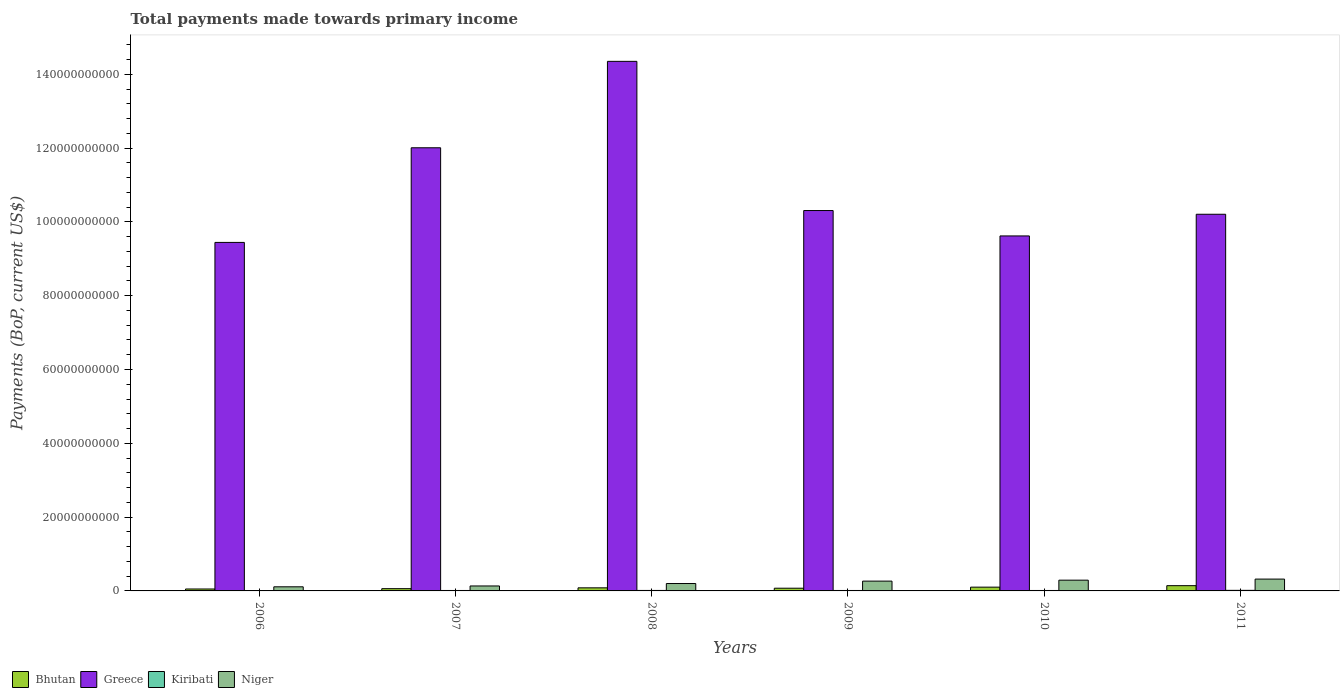Are the number of bars per tick equal to the number of legend labels?
Your answer should be very brief. Yes. Are the number of bars on each tick of the X-axis equal?
Your response must be concise. Yes. What is the label of the 3rd group of bars from the left?
Offer a terse response. 2008. In how many cases, is the number of bars for a given year not equal to the number of legend labels?
Give a very brief answer. 0. What is the total payments made towards primary income in Niger in 2008?
Provide a succinct answer. 2.01e+09. Across all years, what is the maximum total payments made towards primary income in Niger?
Your response must be concise. 3.21e+09. Across all years, what is the minimum total payments made towards primary income in Niger?
Offer a very short reply. 1.12e+09. In which year was the total payments made towards primary income in Greece minimum?
Keep it short and to the point. 2006. What is the total total payments made towards primary income in Niger in the graph?
Ensure brevity in your answer.  1.32e+1. What is the difference between the total payments made towards primary income in Niger in 2010 and that in 2011?
Your answer should be very brief. -2.90e+08. What is the difference between the total payments made towards primary income in Kiribati in 2008 and the total payments made towards primary income in Greece in 2010?
Make the answer very short. -9.61e+1. What is the average total payments made towards primary income in Kiribati per year?
Offer a terse response. 1.24e+08. In the year 2008, what is the difference between the total payments made towards primary income in Greece and total payments made towards primary income in Niger?
Ensure brevity in your answer.  1.42e+11. In how many years, is the total payments made towards primary income in Greece greater than 72000000000 US$?
Your answer should be compact. 6. What is the ratio of the total payments made towards primary income in Niger in 2007 to that in 2011?
Provide a succinct answer. 0.42. Is the difference between the total payments made towards primary income in Greece in 2007 and 2009 greater than the difference between the total payments made towards primary income in Niger in 2007 and 2009?
Ensure brevity in your answer.  Yes. What is the difference between the highest and the second highest total payments made towards primary income in Niger?
Your answer should be compact. 2.90e+08. What is the difference between the highest and the lowest total payments made towards primary income in Kiribati?
Provide a short and direct response. 5.52e+07. In how many years, is the total payments made towards primary income in Niger greater than the average total payments made towards primary income in Niger taken over all years?
Provide a short and direct response. 3. Is the sum of the total payments made towards primary income in Bhutan in 2006 and 2011 greater than the maximum total payments made towards primary income in Kiribati across all years?
Provide a succinct answer. Yes. Is it the case that in every year, the sum of the total payments made towards primary income in Bhutan and total payments made towards primary income in Kiribati is greater than the sum of total payments made towards primary income in Niger and total payments made towards primary income in Greece?
Offer a terse response. No. What does the 1st bar from the left in 2006 represents?
Make the answer very short. Bhutan. What does the 1st bar from the right in 2006 represents?
Keep it short and to the point. Niger. Is it the case that in every year, the sum of the total payments made towards primary income in Kiribati and total payments made towards primary income in Niger is greater than the total payments made towards primary income in Bhutan?
Offer a terse response. Yes. How many bars are there?
Your answer should be very brief. 24. How many years are there in the graph?
Make the answer very short. 6. What is the difference between two consecutive major ticks on the Y-axis?
Offer a terse response. 2.00e+1. Does the graph contain grids?
Provide a short and direct response. No. How are the legend labels stacked?
Make the answer very short. Horizontal. What is the title of the graph?
Offer a terse response. Total payments made towards primary income. Does "Sudan" appear as one of the legend labels in the graph?
Keep it short and to the point. No. What is the label or title of the Y-axis?
Provide a short and direct response. Payments (BoP, current US$). What is the Payments (BoP, current US$) in Bhutan in 2006?
Make the answer very short. 5.25e+08. What is the Payments (BoP, current US$) of Greece in 2006?
Make the answer very short. 9.44e+1. What is the Payments (BoP, current US$) of Kiribati in 2006?
Keep it short and to the point. 9.98e+07. What is the Payments (BoP, current US$) of Niger in 2006?
Provide a short and direct response. 1.12e+09. What is the Payments (BoP, current US$) in Bhutan in 2007?
Keep it short and to the point. 6.13e+08. What is the Payments (BoP, current US$) in Greece in 2007?
Keep it short and to the point. 1.20e+11. What is the Payments (BoP, current US$) in Kiribati in 2007?
Provide a succinct answer. 1.19e+08. What is the Payments (BoP, current US$) in Niger in 2007?
Provide a succinct answer. 1.34e+09. What is the Payments (BoP, current US$) in Bhutan in 2008?
Your response must be concise. 8.35e+08. What is the Payments (BoP, current US$) in Greece in 2008?
Ensure brevity in your answer.  1.44e+11. What is the Payments (BoP, current US$) of Kiribati in 2008?
Your answer should be very brief. 1.30e+08. What is the Payments (BoP, current US$) of Niger in 2008?
Give a very brief answer. 2.01e+09. What is the Payments (BoP, current US$) in Bhutan in 2009?
Keep it short and to the point. 7.35e+08. What is the Payments (BoP, current US$) in Greece in 2009?
Keep it short and to the point. 1.03e+11. What is the Payments (BoP, current US$) of Kiribati in 2009?
Offer a terse response. 1.20e+08. What is the Payments (BoP, current US$) of Niger in 2009?
Keep it short and to the point. 2.66e+09. What is the Payments (BoP, current US$) of Bhutan in 2010?
Make the answer very short. 1.02e+09. What is the Payments (BoP, current US$) in Greece in 2010?
Ensure brevity in your answer.  9.62e+1. What is the Payments (BoP, current US$) in Kiribati in 2010?
Offer a terse response. 1.21e+08. What is the Payments (BoP, current US$) in Niger in 2010?
Your response must be concise. 2.92e+09. What is the Payments (BoP, current US$) in Bhutan in 2011?
Make the answer very short. 1.43e+09. What is the Payments (BoP, current US$) in Greece in 2011?
Keep it short and to the point. 1.02e+11. What is the Payments (BoP, current US$) of Kiribati in 2011?
Your response must be concise. 1.55e+08. What is the Payments (BoP, current US$) in Niger in 2011?
Your response must be concise. 3.21e+09. Across all years, what is the maximum Payments (BoP, current US$) of Bhutan?
Make the answer very short. 1.43e+09. Across all years, what is the maximum Payments (BoP, current US$) in Greece?
Your response must be concise. 1.44e+11. Across all years, what is the maximum Payments (BoP, current US$) in Kiribati?
Provide a short and direct response. 1.55e+08. Across all years, what is the maximum Payments (BoP, current US$) of Niger?
Offer a very short reply. 3.21e+09. Across all years, what is the minimum Payments (BoP, current US$) of Bhutan?
Keep it short and to the point. 5.25e+08. Across all years, what is the minimum Payments (BoP, current US$) in Greece?
Offer a very short reply. 9.44e+1. Across all years, what is the minimum Payments (BoP, current US$) in Kiribati?
Provide a succinct answer. 9.98e+07. Across all years, what is the minimum Payments (BoP, current US$) of Niger?
Give a very brief answer. 1.12e+09. What is the total Payments (BoP, current US$) in Bhutan in the graph?
Give a very brief answer. 5.16e+09. What is the total Payments (BoP, current US$) in Greece in the graph?
Offer a very short reply. 6.59e+11. What is the total Payments (BoP, current US$) of Kiribati in the graph?
Provide a succinct answer. 7.46e+08. What is the total Payments (BoP, current US$) in Niger in the graph?
Your answer should be very brief. 1.32e+1. What is the difference between the Payments (BoP, current US$) in Bhutan in 2006 and that in 2007?
Your answer should be compact. -8.84e+07. What is the difference between the Payments (BoP, current US$) in Greece in 2006 and that in 2007?
Provide a short and direct response. -2.56e+1. What is the difference between the Payments (BoP, current US$) of Kiribati in 2006 and that in 2007?
Ensure brevity in your answer.  -1.92e+07. What is the difference between the Payments (BoP, current US$) of Niger in 2006 and that in 2007?
Provide a succinct answer. -2.25e+08. What is the difference between the Payments (BoP, current US$) of Bhutan in 2006 and that in 2008?
Your response must be concise. -3.11e+08. What is the difference between the Payments (BoP, current US$) of Greece in 2006 and that in 2008?
Your answer should be compact. -4.91e+1. What is the difference between the Payments (BoP, current US$) in Kiribati in 2006 and that in 2008?
Provide a succinct answer. -3.06e+07. What is the difference between the Payments (BoP, current US$) of Niger in 2006 and that in 2008?
Your answer should be very brief. -8.89e+08. What is the difference between the Payments (BoP, current US$) of Bhutan in 2006 and that in 2009?
Keep it short and to the point. -2.10e+08. What is the difference between the Payments (BoP, current US$) of Greece in 2006 and that in 2009?
Keep it short and to the point. -8.64e+09. What is the difference between the Payments (BoP, current US$) of Kiribati in 2006 and that in 2009?
Ensure brevity in your answer.  -2.04e+07. What is the difference between the Payments (BoP, current US$) of Niger in 2006 and that in 2009?
Offer a terse response. -1.54e+09. What is the difference between the Payments (BoP, current US$) of Bhutan in 2006 and that in 2010?
Make the answer very short. -4.99e+08. What is the difference between the Payments (BoP, current US$) in Greece in 2006 and that in 2010?
Offer a terse response. -1.76e+09. What is the difference between the Payments (BoP, current US$) of Kiribati in 2006 and that in 2010?
Your response must be concise. -2.11e+07. What is the difference between the Payments (BoP, current US$) in Niger in 2006 and that in 2010?
Your answer should be very brief. -1.80e+09. What is the difference between the Payments (BoP, current US$) in Bhutan in 2006 and that in 2011?
Provide a succinct answer. -9.01e+08. What is the difference between the Payments (BoP, current US$) in Greece in 2006 and that in 2011?
Give a very brief answer. -7.63e+09. What is the difference between the Payments (BoP, current US$) of Kiribati in 2006 and that in 2011?
Provide a succinct answer. -5.52e+07. What is the difference between the Payments (BoP, current US$) in Niger in 2006 and that in 2011?
Offer a very short reply. -2.09e+09. What is the difference between the Payments (BoP, current US$) of Bhutan in 2007 and that in 2008?
Keep it short and to the point. -2.22e+08. What is the difference between the Payments (BoP, current US$) of Greece in 2007 and that in 2008?
Give a very brief answer. -2.34e+1. What is the difference between the Payments (BoP, current US$) of Kiribati in 2007 and that in 2008?
Offer a terse response. -1.14e+07. What is the difference between the Payments (BoP, current US$) of Niger in 2007 and that in 2008?
Make the answer very short. -6.63e+08. What is the difference between the Payments (BoP, current US$) of Bhutan in 2007 and that in 2009?
Make the answer very short. -1.22e+08. What is the difference between the Payments (BoP, current US$) in Greece in 2007 and that in 2009?
Give a very brief answer. 1.70e+1. What is the difference between the Payments (BoP, current US$) of Kiribati in 2007 and that in 2009?
Offer a terse response. -1.23e+06. What is the difference between the Payments (BoP, current US$) in Niger in 2007 and that in 2009?
Provide a succinct answer. -1.31e+09. What is the difference between the Payments (BoP, current US$) of Bhutan in 2007 and that in 2010?
Make the answer very short. -4.11e+08. What is the difference between the Payments (BoP, current US$) in Greece in 2007 and that in 2010?
Your answer should be very brief. 2.39e+1. What is the difference between the Payments (BoP, current US$) in Kiribati in 2007 and that in 2010?
Keep it short and to the point. -1.95e+06. What is the difference between the Payments (BoP, current US$) in Niger in 2007 and that in 2010?
Your answer should be compact. -1.57e+09. What is the difference between the Payments (BoP, current US$) of Bhutan in 2007 and that in 2011?
Give a very brief answer. -8.12e+08. What is the difference between the Payments (BoP, current US$) in Greece in 2007 and that in 2011?
Provide a short and direct response. 1.80e+1. What is the difference between the Payments (BoP, current US$) in Kiribati in 2007 and that in 2011?
Ensure brevity in your answer.  -3.61e+07. What is the difference between the Payments (BoP, current US$) of Niger in 2007 and that in 2011?
Offer a very short reply. -1.86e+09. What is the difference between the Payments (BoP, current US$) in Bhutan in 2008 and that in 2009?
Offer a very short reply. 1.00e+08. What is the difference between the Payments (BoP, current US$) in Greece in 2008 and that in 2009?
Offer a very short reply. 4.04e+1. What is the difference between the Payments (BoP, current US$) of Kiribati in 2008 and that in 2009?
Provide a short and direct response. 1.02e+07. What is the difference between the Payments (BoP, current US$) in Niger in 2008 and that in 2009?
Provide a short and direct response. -6.50e+08. What is the difference between the Payments (BoP, current US$) of Bhutan in 2008 and that in 2010?
Offer a very short reply. -1.88e+08. What is the difference between the Payments (BoP, current US$) in Greece in 2008 and that in 2010?
Your answer should be very brief. 4.73e+1. What is the difference between the Payments (BoP, current US$) in Kiribati in 2008 and that in 2010?
Offer a terse response. 9.45e+06. What is the difference between the Payments (BoP, current US$) of Niger in 2008 and that in 2010?
Make the answer very short. -9.10e+08. What is the difference between the Payments (BoP, current US$) in Bhutan in 2008 and that in 2011?
Your answer should be compact. -5.90e+08. What is the difference between the Payments (BoP, current US$) in Greece in 2008 and that in 2011?
Your response must be concise. 4.14e+1. What is the difference between the Payments (BoP, current US$) of Kiribati in 2008 and that in 2011?
Keep it short and to the point. -2.46e+07. What is the difference between the Payments (BoP, current US$) of Niger in 2008 and that in 2011?
Ensure brevity in your answer.  -1.20e+09. What is the difference between the Payments (BoP, current US$) of Bhutan in 2009 and that in 2010?
Your answer should be compact. -2.89e+08. What is the difference between the Payments (BoP, current US$) of Greece in 2009 and that in 2010?
Give a very brief answer. 6.88e+09. What is the difference between the Payments (BoP, current US$) of Kiribati in 2009 and that in 2010?
Your answer should be very brief. -7.21e+05. What is the difference between the Payments (BoP, current US$) of Niger in 2009 and that in 2010?
Ensure brevity in your answer.  -2.59e+08. What is the difference between the Payments (BoP, current US$) in Bhutan in 2009 and that in 2011?
Provide a succinct answer. -6.90e+08. What is the difference between the Payments (BoP, current US$) in Greece in 2009 and that in 2011?
Offer a terse response. 1.01e+09. What is the difference between the Payments (BoP, current US$) in Kiribati in 2009 and that in 2011?
Your answer should be very brief. -3.48e+07. What is the difference between the Payments (BoP, current US$) of Niger in 2009 and that in 2011?
Ensure brevity in your answer.  -5.50e+08. What is the difference between the Payments (BoP, current US$) of Bhutan in 2010 and that in 2011?
Your answer should be very brief. -4.02e+08. What is the difference between the Payments (BoP, current US$) of Greece in 2010 and that in 2011?
Your response must be concise. -5.87e+09. What is the difference between the Payments (BoP, current US$) in Kiribati in 2010 and that in 2011?
Make the answer very short. -3.41e+07. What is the difference between the Payments (BoP, current US$) of Niger in 2010 and that in 2011?
Your response must be concise. -2.90e+08. What is the difference between the Payments (BoP, current US$) in Bhutan in 2006 and the Payments (BoP, current US$) in Greece in 2007?
Provide a short and direct response. -1.20e+11. What is the difference between the Payments (BoP, current US$) of Bhutan in 2006 and the Payments (BoP, current US$) of Kiribati in 2007?
Keep it short and to the point. 4.06e+08. What is the difference between the Payments (BoP, current US$) of Bhutan in 2006 and the Payments (BoP, current US$) of Niger in 2007?
Your answer should be compact. -8.18e+08. What is the difference between the Payments (BoP, current US$) of Greece in 2006 and the Payments (BoP, current US$) of Kiribati in 2007?
Keep it short and to the point. 9.43e+1. What is the difference between the Payments (BoP, current US$) in Greece in 2006 and the Payments (BoP, current US$) in Niger in 2007?
Your response must be concise. 9.31e+1. What is the difference between the Payments (BoP, current US$) in Kiribati in 2006 and the Payments (BoP, current US$) in Niger in 2007?
Keep it short and to the point. -1.24e+09. What is the difference between the Payments (BoP, current US$) in Bhutan in 2006 and the Payments (BoP, current US$) in Greece in 2008?
Your response must be concise. -1.43e+11. What is the difference between the Payments (BoP, current US$) of Bhutan in 2006 and the Payments (BoP, current US$) of Kiribati in 2008?
Keep it short and to the point. 3.94e+08. What is the difference between the Payments (BoP, current US$) in Bhutan in 2006 and the Payments (BoP, current US$) in Niger in 2008?
Your answer should be compact. -1.48e+09. What is the difference between the Payments (BoP, current US$) in Greece in 2006 and the Payments (BoP, current US$) in Kiribati in 2008?
Ensure brevity in your answer.  9.43e+1. What is the difference between the Payments (BoP, current US$) of Greece in 2006 and the Payments (BoP, current US$) of Niger in 2008?
Offer a very short reply. 9.24e+1. What is the difference between the Payments (BoP, current US$) of Kiribati in 2006 and the Payments (BoP, current US$) of Niger in 2008?
Your answer should be very brief. -1.91e+09. What is the difference between the Payments (BoP, current US$) in Bhutan in 2006 and the Payments (BoP, current US$) in Greece in 2009?
Provide a succinct answer. -1.03e+11. What is the difference between the Payments (BoP, current US$) in Bhutan in 2006 and the Payments (BoP, current US$) in Kiribati in 2009?
Provide a succinct answer. 4.04e+08. What is the difference between the Payments (BoP, current US$) of Bhutan in 2006 and the Payments (BoP, current US$) of Niger in 2009?
Your response must be concise. -2.13e+09. What is the difference between the Payments (BoP, current US$) of Greece in 2006 and the Payments (BoP, current US$) of Kiribati in 2009?
Offer a very short reply. 9.43e+1. What is the difference between the Payments (BoP, current US$) of Greece in 2006 and the Payments (BoP, current US$) of Niger in 2009?
Ensure brevity in your answer.  9.18e+1. What is the difference between the Payments (BoP, current US$) of Kiribati in 2006 and the Payments (BoP, current US$) of Niger in 2009?
Your answer should be very brief. -2.56e+09. What is the difference between the Payments (BoP, current US$) of Bhutan in 2006 and the Payments (BoP, current US$) of Greece in 2010?
Offer a very short reply. -9.57e+1. What is the difference between the Payments (BoP, current US$) of Bhutan in 2006 and the Payments (BoP, current US$) of Kiribati in 2010?
Offer a terse response. 4.04e+08. What is the difference between the Payments (BoP, current US$) of Bhutan in 2006 and the Payments (BoP, current US$) of Niger in 2010?
Your answer should be very brief. -2.39e+09. What is the difference between the Payments (BoP, current US$) of Greece in 2006 and the Payments (BoP, current US$) of Kiribati in 2010?
Your answer should be compact. 9.43e+1. What is the difference between the Payments (BoP, current US$) of Greece in 2006 and the Payments (BoP, current US$) of Niger in 2010?
Ensure brevity in your answer.  9.15e+1. What is the difference between the Payments (BoP, current US$) in Kiribati in 2006 and the Payments (BoP, current US$) in Niger in 2010?
Give a very brief answer. -2.82e+09. What is the difference between the Payments (BoP, current US$) of Bhutan in 2006 and the Payments (BoP, current US$) of Greece in 2011?
Make the answer very short. -1.02e+11. What is the difference between the Payments (BoP, current US$) in Bhutan in 2006 and the Payments (BoP, current US$) in Kiribati in 2011?
Offer a very short reply. 3.69e+08. What is the difference between the Payments (BoP, current US$) of Bhutan in 2006 and the Payments (BoP, current US$) of Niger in 2011?
Offer a very short reply. -2.68e+09. What is the difference between the Payments (BoP, current US$) of Greece in 2006 and the Payments (BoP, current US$) of Kiribati in 2011?
Offer a very short reply. 9.43e+1. What is the difference between the Payments (BoP, current US$) of Greece in 2006 and the Payments (BoP, current US$) of Niger in 2011?
Keep it short and to the point. 9.12e+1. What is the difference between the Payments (BoP, current US$) of Kiribati in 2006 and the Payments (BoP, current US$) of Niger in 2011?
Keep it short and to the point. -3.11e+09. What is the difference between the Payments (BoP, current US$) of Bhutan in 2007 and the Payments (BoP, current US$) of Greece in 2008?
Keep it short and to the point. -1.43e+11. What is the difference between the Payments (BoP, current US$) in Bhutan in 2007 and the Payments (BoP, current US$) in Kiribati in 2008?
Give a very brief answer. 4.83e+08. What is the difference between the Payments (BoP, current US$) in Bhutan in 2007 and the Payments (BoP, current US$) in Niger in 2008?
Provide a succinct answer. -1.39e+09. What is the difference between the Payments (BoP, current US$) in Greece in 2007 and the Payments (BoP, current US$) in Kiribati in 2008?
Ensure brevity in your answer.  1.20e+11. What is the difference between the Payments (BoP, current US$) of Greece in 2007 and the Payments (BoP, current US$) of Niger in 2008?
Your answer should be compact. 1.18e+11. What is the difference between the Payments (BoP, current US$) in Kiribati in 2007 and the Payments (BoP, current US$) in Niger in 2008?
Your answer should be very brief. -1.89e+09. What is the difference between the Payments (BoP, current US$) of Bhutan in 2007 and the Payments (BoP, current US$) of Greece in 2009?
Ensure brevity in your answer.  -1.02e+11. What is the difference between the Payments (BoP, current US$) of Bhutan in 2007 and the Payments (BoP, current US$) of Kiribati in 2009?
Give a very brief answer. 4.93e+08. What is the difference between the Payments (BoP, current US$) of Bhutan in 2007 and the Payments (BoP, current US$) of Niger in 2009?
Offer a terse response. -2.04e+09. What is the difference between the Payments (BoP, current US$) in Greece in 2007 and the Payments (BoP, current US$) in Kiribati in 2009?
Give a very brief answer. 1.20e+11. What is the difference between the Payments (BoP, current US$) of Greece in 2007 and the Payments (BoP, current US$) of Niger in 2009?
Your response must be concise. 1.17e+11. What is the difference between the Payments (BoP, current US$) of Kiribati in 2007 and the Payments (BoP, current US$) of Niger in 2009?
Keep it short and to the point. -2.54e+09. What is the difference between the Payments (BoP, current US$) in Bhutan in 2007 and the Payments (BoP, current US$) in Greece in 2010?
Offer a terse response. -9.56e+1. What is the difference between the Payments (BoP, current US$) of Bhutan in 2007 and the Payments (BoP, current US$) of Kiribati in 2010?
Your response must be concise. 4.92e+08. What is the difference between the Payments (BoP, current US$) of Bhutan in 2007 and the Payments (BoP, current US$) of Niger in 2010?
Offer a very short reply. -2.30e+09. What is the difference between the Payments (BoP, current US$) of Greece in 2007 and the Payments (BoP, current US$) of Kiribati in 2010?
Make the answer very short. 1.20e+11. What is the difference between the Payments (BoP, current US$) of Greece in 2007 and the Payments (BoP, current US$) of Niger in 2010?
Keep it short and to the point. 1.17e+11. What is the difference between the Payments (BoP, current US$) of Kiribati in 2007 and the Payments (BoP, current US$) of Niger in 2010?
Provide a succinct answer. -2.80e+09. What is the difference between the Payments (BoP, current US$) in Bhutan in 2007 and the Payments (BoP, current US$) in Greece in 2011?
Keep it short and to the point. -1.01e+11. What is the difference between the Payments (BoP, current US$) in Bhutan in 2007 and the Payments (BoP, current US$) in Kiribati in 2011?
Ensure brevity in your answer.  4.58e+08. What is the difference between the Payments (BoP, current US$) of Bhutan in 2007 and the Payments (BoP, current US$) of Niger in 2011?
Give a very brief answer. -2.59e+09. What is the difference between the Payments (BoP, current US$) in Greece in 2007 and the Payments (BoP, current US$) in Kiribati in 2011?
Your answer should be compact. 1.20e+11. What is the difference between the Payments (BoP, current US$) in Greece in 2007 and the Payments (BoP, current US$) in Niger in 2011?
Provide a short and direct response. 1.17e+11. What is the difference between the Payments (BoP, current US$) of Kiribati in 2007 and the Payments (BoP, current US$) of Niger in 2011?
Offer a very short reply. -3.09e+09. What is the difference between the Payments (BoP, current US$) in Bhutan in 2008 and the Payments (BoP, current US$) in Greece in 2009?
Make the answer very short. -1.02e+11. What is the difference between the Payments (BoP, current US$) in Bhutan in 2008 and the Payments (BoP, current US$) in Kiribati in 2009?
Your response must be concise. 7.15e+08. What is the difference between the Payments (BoP, current US$) of Bhutan in 2008 and the Payments (BoP, current US$) of Niger in 2009?
Provide a succinct answer. -1.82e+09. What is the difference between the Payments (BoP, current US$) in Greece in 2008 and the Payments (BoP, current US$) in Kiribati in 2009?
Your answer should be compact. 1.43e+11. What is the difference between the Payments (BoP, current US$) of Greece in 2008 and the Payments (BoP, current US$) of Niger in 2009?
Offer a very short reply. 1.41e+11. What is the difference between the Payments (BoP, current US$) of Kiribati in 2008 and the Payments (BoP, current US$) of Niger in 2009?
Ensure brevity in your answer.  -2.53e+09. What is the difference between the Payments (BoP, current US$) in Bhutan in 2008 and the Payments (BoP, current US$) in Greece in 2010?
Offer a very short reply. -9.54e+1. What is the difference between the Payments (BoP, current US$) in Bhutan in 2008 and the Payments (BoP, current US$) in Kiribati in 2010?
Your response must be concise. 7.14e+08. What is the difference between the Payments (BoP, current US$) in Bhutan in 2008 and the Payments (BoP, current US$) in Niger in 2010?
Your answer should be very brief. -2.08e+09. What is the difference between the Payments (BoP, current US$) in Greece in 2008 and the Payments (BoP, current US$) in Kiribati in 2010?
Offer a terse response. 1.43e+11. What is the difference between the Payments (BoP, current US$) in Greece in 2008 and the Payments (BoP, current US$) in Niger in 2010?
Ensure brevity in your answer.  1.41e+11. What is the difference between the Payments (BoP, current US$) of Kiribati in 2008 and the Payments (BoP, current US$) of Niger in 2010?
Make the answer very short. -2.79e+09. What is the difference between the Payments (BoP, current US$) of Bhutan in 2008 and the Payments (BoP, current US$) of Greece in 2011?
Provide a succinct answer. -1.01e+11. What is the difference between the Payments (BoP, current US$) in Bhutan in 2008 and the Payments (BoP, current US$) in Kiribati in 2011?
Ensure brevity in your answer.  6.80e+08. What is the difference between the Payments (BoP, current US$) in Bhutan in 2008 and the Payments (BoP, current US$) in Niger in 2011?
Keep it short and to the point. -2.37e+09. What is the difference between the Payments (BoP, current US$) in Greece in 2008 and the Payments (BoP, current US$) in Kiribati in 2011?
Your response must be concise. 1.43e+11. What is the difference between the Payments (BoP, current US$) of Greece in 2008 and the Payments (BoP, current US$) of Niger in 2011?
Your answer should be compact. 1.40e+11. What is the difference between the Payments (BoP, current US$) in Kiribati in 2008 and the Payments (BoP, current US$) in Niger in 2011?
Offer a very short reply. -3.08e+09. What is the difference between the Payments (BoP, current US$) in Bhutan in 2009 and the Payments (BoP, current US$) in Greece in 2010?
Give a very brief answer. -9.55e+1. What is the difference between the Payments (BoP, current US$) of Bhutan in 2009 and the Payments (BoP, current US$) of Kiribati in 2010?
Ensure brevity in your answer.  6.14e+08. What is the difference between the Payments (BoP, current US$) in Bhutan in 2009 and the Payments (BoP, current US$) in Niger in 2010?
Keep it short and to the point. -2.18e+09. What is the difference between the Payments (BoP, current US$) in Greece in 2009 and the Payments (BoP, current US$) in Kiribati in 2010?
Make the answer very short. 1.03e+11. What is the difference between the Payments (BoP, current US$) of Greece in 2009 and the Payments (BoP, current US$) of Niger in 2010?
Ensure brevity in your answer.  1.00e+11. What is the difference between the Payments (BoP, current US$) in Kiribati in 2009 and the Payments (BoP, current US$) in Niger in 2010?
Make the answer very short. -2.80e+09. What is the difference between the Payments (BoP, current US$) in Bhutan in 2009 and the Payments (BoP, current US$) in Greece in 2011?
Your answer should be compact. -1.01e+11. What is the difference between the Payments (BoP, current US$) in Bhutan in 2009 and the Payments (BoP, current US$) in Kiribati in 2011?
Your response must be concise. 5.80e+08. What is the difference between the Payments (BoP, current US$) of Bhutan in 2009 and the Payments (BoP, current US$) of Niger in 2011?
Make the answer very short. -2.47e+09. What is the difference between the Payments (BoP, current US$) in Greece in 2009 and the Payments (BoP, current US$) in Kiribati in 2011?
Give a very brief answer. 1.03e+11. What is the difference between the Payments (BoP, current US$) in Greece in 2009 and the Payments (BoP, current US$) in Niger in 2011?
Give a very brief answer. 9.99e+1. What is the difference between the Payments (BoP, current US$) in Kiribati in 2009 and the Payments (BoP, current US$) in Niger in 2011?
Keep it short and to the point. -3.09e+09. What is the difference between the Payments (BoP, current US$) of Bhutan in 2010 and the Payments (BoP, current US$) of Greece in 2011?
Provide a short and direct response. -1.01e+11. What is the difference between the Payments (BoP, current US$) in Bhutan in 2010 and the Payments (BoP, current US$) in Kiribati in 2011?
Offer a very short reply. 8.69e+08. What is the difference between the Payments (BoP, current US$) of Bhutan in 2010 and the Payments (BoP, current US$) of Niger in 2011?
Your answer should be compact. -2.18e+09. What is the difference between the Payments (BoP, current US$) in Greece in 2010 and the Payments (BoP, current US$) in Kiribati in 2011?
Offer a terse response. 9.60e+1. What is the difference between the Payments (BoP, current US$) of Greece in 2010 and the Payments (BoP, current US$) of Niger in 2011?
Keep it short and to the point. 9.30e+1. What is the difference between the Payments (BoP, current US$) of Kiribati in 2010 and the Payments (BoP, current US$) of Niger in 2011?
Provide a short and direct response. -3.09e+09. What is the average Payments (BoP, current US$) in Bhutan per year?
Provide a succinct answer. 8.59e+08. What is the average Payments (BoP, current US$) of Greece per year?
Ensure brevity in your answer.  1.10e+11. What is the average Payments (BoP, current US$) of Kiribati per year?
Ensure brevity in your answer.  1.24e+08. What is the average Payments (BoP, current US$) of Niger per year?
Give a very brief answer. 2.21e+09. In the year 2006, what is the difference between the Payments (BoP, current US$) of Bhutan and Payments (BoP, current US$) of Greece?
Your response must be concise. -9.39e+1. In the year 2006, what is the difference between the Payments (BoP, current US$) in Bhutan and Payments (BoP, current US$) in Kiribati?
Make the answer very short. 4.25e+08. In the year 2006, what is the difference between the Payments (BoP, current US$) of Bhutan and Payments (BoP, current US$) of Niger?
Offer a terse response. -5.93e+08. In the year 2006, what is the difference between the Payments (BoP, current US$) of Greece and Payments (BoP, current US$) of Kiribati?
Your answer should be compact. 9.43e+1. In the year 2006, what is the difference between the Payments (BoP, current US$) of Greece and Payments (BoP, current US$) of Niger?
Your answer should be very brief. 9.33e+1. In the year 2006, what is the difference between the Payments (BoP, current US$) of Kiribati and Payments (BoP, current US$) of Niger?
Make the answer very short. -1.02e+09. In the year 2007, what is the difference between the Payments (BoP, current US$) of Bhutan and Payments (BoP, current US$) of Greece?
Keep it short and to the point. -1.19e+11. In the year 2007, what is the difference between the Payments (BoP, current US$) in Bhutan and Payments (BoP, current US$) in Kiribati?
Your answer should be compact. 4.94e+08. In the year 2007, what is the difference between the Payments (BoP, current US$) of Bhutan and Payments (BoP, current US$) of Niger?
Keep it short and to the point. -7.30e+08. In the year 2007, what is the difference between the Payments (BoP, current US$) in Greece and Payments (BoP, current US$) in Kiribati?
Give a very brief answer. 1.20e+11. In the year 2007, what is the difference between the Payments (BoP, current US$) in Greece and Payments (BoP, current US$) in Niger?
Provide a succinct answer. 1.19e+11. In the year 2007, what is the difference between the Payments (BoP, current US$) in Kiribati and Payments (BoP, current US$) in Niger?
Ensure brevity in your answer.  -1.22e+09. In the year 2008, what is the difference between the Payments (BoP, current US$) of Bhutan and Payments (BoP, current US$) of Greece?
Your answer should be compact. -1.43e+11. In the year 2008, what is the difference between the Payments (BoP, current US$) in Bhutan and Payments (BoP, current US$) in Kiribati?
Provide a succinct answer. 7.05e+08. In the year 2008, what is the difference between the Payments (BoP, current US$) of Bhutan and Payments (BoP, current US$) of Niger?
Your answer should be very brief. -1.17e+09. In the year 2008, what is the difference between the Payments (BoP, current US$) in Greece and Payments (BoP, current US$) in Kiribati?
Provide a short and direct response. 1.43e+11. In the year 2008, what is the difference between the Payments (BoP, current US$) in Greece and Payments (BoP, current US$) in Niger?
Ensure brevity in your answer.  1.42e+11. In the year 2008, what is the difference between the Payments (BoP, current US$) in Kiribati and Payments (BoP, current US$) in Niger?
Your answer should be compact. -1.88e+09. In the year 2009, what is the difference between the Payments (BoP, current US$) of Bhutan and Payments (BoP, current US$) of Greece?
Make the answer very short. -1.02e+11. In the year 2009, what is the difference between the Payments (BoP, current US$) of Bhutan and Payments (BoP, current US$) of Kiribati?
Offer a very short reply. 6.15e+08. In the year 2009, what is the difference between the Payments (BoP, current US$) in Bhutan and Payments (BoP, current US$) in Niger?
Ensure brevity in your answer.  -1.92e+09. In the year 2009, what is the difference between the Payments (BoP, current US$) in Greece and Payments (BoP, current US$) in Kiribati?
Your answer should be compact. 1.03e+11. In the year 2009, what is the difference between the Payments (BoP, current US$) in Greece and Payments (BoP, current US$) in Niger?
Your answer should be very brief. 1.00e+11. In the year 2009, what is the difference between the Payments (BoP, current US$) of Kiribati and Payments (BoP, current US$) of Niger?
Your answer should be very brief. -2.54e+09. In the year 2010, what is the difference between the Payments (BoP, current US$) in Bhutan and Payments (BoP, current US$) in Greece?
Provide a succinct answer. -9.52e+1. In the year 2010, what is the difference between the Payments (BoP, current US$) in Bhutan and Payments (BoP, current US$) in Kiribati?
Provide a succinct answer. 9.03e+08. In the year 2010, what is the difference between the Payments (BoP, current US$) of Bhutan and Payments (BoP, current US$) of Niger?
Your response must be concise. -1.89e+09. In the year 2010, what is the difference between the Payments (BoP, current US$) in Greece and Payments (BoP, current US$) in Kiribati?
Offer a very short reply. 9.61e+1. In the year 2010, what is the difference between the Payments (BoP, current US$) in Greece and Payments (BoP, current US$) in Niger?
Offer a very short reply. 9.33e+1. In the year 2010, what is the difference between the Payments (BoP, current US$) in Kiribati and Payments (BoP, current US$) in Niger?
Offer a terse response. -2.80e+09. In the year 2011, what is the difference between the Payments (BoP, current US$) in Bhutan and Payments (BoP, current US$) in Greece?
Make the answer very short. -1.01e+11. In the year 2011, what is the difference between the Payments (BoP, current US$) of Bhutan and Payments (BoP, current US$) of Kiribati?
Your answer should be compact. 1.27e+09. In the year 2011, what is the difference between the Payments (BoP, current US$) in Bhutan and Payments (BoP, current US$) in Niger?
Your response must be concise. -1.78e+09. In the year 2011, what is the difference between the Payments (BoP, current US$) in Greece and Payments (BoP, current US$) in Kiribati?
Offer a very short reply. 1.02e+11. In the year 2011, what is the difference between the Payments (BoP, current US$) in Greece and Payments (BoP, current US$) in Niger?
Make the answer very short. 9.89e+1. In the year 2011, what is the difference between the Payments (BoP, current US$) of Kiribati and Payments (BoP, current US$) of Niger?
Make the answer very short. -3.05e+09. What is the ratio of the Payments (BoP, current US$) in Bhutan in 2006 to that in 2007?
Make the answer very short. 0.86. What is the ratio of the Payments (BoP, current US$) in Greece in 2006 to that in 2007?
Your answer should be very brief. 0.79. What is the ratio of the Payments (BoP, current US$) in Kiribati in 2006 to that in 2007?
Keep it short and to the point. 0.84. What is the ratio of the Payments (BoP, current US$) of Niger in 2006 to that in 2007?
Provide a succinct answer. 0.83. What is the ratio of the Payments (BoP, current US$) of Bhutan in 2006 to that in 2008?
Provide a succinct answer. 0.63. What is the ratio of the Payments (BoP, current US$) in Greece in 2006 to that in 2008?
Your answer should be very brief. 0.66. What is the ratio of the Payments (BoP, current US$) of Kiribati in 2006 to that in 2008?
Make the answer very short. 0.77. What is the ratio of the Payments (BoP, current US$) in Niger in 2006 to that in 2008?
Your answer should be compact. 0.56. What is the ratio of the Payments (BoP, current US$) of Bhutan in 2006 to that in 2009?
Your answer should be compact. 0.71. What is the ratio of the Payments (BoP, current US$) of Greece in 2006 to that in 2009?
Give a very brief answer. 0.92. What is the ratio of the Payments (BoP, current US$) of Kiribati in 2006 to that in 2009?
Your answer should be very brief. 0.83. What is the ratio of the Payments (BoP, current US$) of Niger in 2006 to that in 2009?
Keep it short and to the point. 0.42. What is the ratio of the Payments (BoP, current US$) in Bhutan in 2006 to that in 2010?
Your answer should be very brief. 0.51. What is the ratio of the Payments (BoP, current US$) of Greece in 2006 to that in 2010?
Ensure brevity in your answer.  0.98. What is the ratio of the Payments (BoP, current US$) in Kiribati in 2006 to that in 2010?
Ensure brevity in your answer.  0.83. What is the ratio of the Payments (BoP, current US$) in Niger in 2006 to that in 2010?
Your response must be concise. 0.38. What is the ratio of the Payments (BoP, current US$) in Bhutan in 2006 to that in 2011?
Your response must be concise. 0.37. What is the ratio of the Payments (BoP, current US$) in Greece in 2006 to that in 2011?
Provide a succinct answer. 0.93. What is the ratio of the Payments (BoP, current US$) in Kiribati in 2006 to that in 2011?
Keep it short and to the point. 0.64. What is the ratio of the Payments (BoP, current US$) in Niger in 2006 to that in 2011?
Make the answer very short. 0.35. What is the ratio of the Payments (BoP, current US$) of Bhutan in 2007 to that in 2008?
Make the answer very short. 0.73. What is the ratio of the Payments (BoP, current US$) in Greece in 2007 to that in 2008?
Offer a very short reply. 0.84. What is the ratio of the Payments (BoP, current US$) in Kiribati in 2007 to that in 2008?
Ensure brevity in your answer.  0.91. What is the ratio of the Payments (BoP, current US$) in Niger in 2007 to that in 2008?
Your answer should be very brief. 0.67. What is the ratio of the Payments (BoP, current US$) of Bhutan in 2007 to that in 2009?
Offer a very short reply. 0.83. What is the ratio of the Payments (BoP, current US$) of Greece in 2007 to that in 2009?
Your answer should be very brief. 1.17. What is the ratio of the Payments (BoP, current US$) of Kiribati in 2007 to that in 2009?
Make the answer very short. 0.99. What is the ratio of the Payments (BoP, current US$) of Niger in 2007 to that in 2009?
Provide a succinct answer. 0.51. What is the ratio of the Payments (BoP, current US$) in Bhutan in 2007 to that in 2010?
Give a very brief answer. 0.6. What is the ratio of the Payments (BoP, current US$) of Greece in 2007 to that in 2010?
Offer a very short reply. 1.25. What is the ratio of the Payments (BoP, current US$) in Kiribati in 2007 to that in 2010?
Offer a terse response. 0.98. What is the ratio of the Payments (BoP, current US$) of Niger in 2007 to that in 2010?
Offer a very short reply. 0.46. What is the ratio of the Payments (BoP, current US$) of Bhutan in 2007 to that in 2011?
Your response must be concise. 0.43. What is the ratio of the Payments (BoP, current US$) in Greece in 2007 to that in 2011?
Give a very brief answer. 1.18. What is the ratio of the Payments (BoP, current US$) in Kiribati in 2007 to that in 2011?
Your answer should be compact. 0.77. What is the ratio of the Payments (BoP, current US$) in Niger in 2007 to that in 2011?
Offer a very short reply. 0.42. What is the ratio of the Payments (BoP, current US$) of Bhutan in 2008 to that in 2009?
Provide a succinct answer. 1.14. What is the ratio of the Payments (BoP, current US$) in Greece in 2008 to that in 2009?
Your response must be concise. 1.39. What is the ratio of the Payments (BoP, current US$) of Kiribati in 2008 to that in 2009?
Offer a terse response. 1.08. What is the ratio of the Payments (BoP, current US$) in Niger in 2008 to that in 2009?
Keep it short and to the point. 0.76. What is the ratio of the Payments (BoP, current US$) in Bhutan in 2008 to that in 2010?
Ensure brevity in your answer.  0.82. What is the ratio of the Payments (BoP, current US$) in Greece in 2008 to that in 2010?
Ensure brevity in your answer.  1.49. What is the ratio of the Payments (BoP, current US$) in Kiribati in 2008 to that in 2010?
Provide a succinct answer. 1.08. What is the ratio of the Payments (BoP, current US$) of Niger in 2008 to that in 2010?
Give a very brief answer. 0.69. What is the ratio of the Payments (BoP, current US$) of Bhutan in 2008 to that in 2011?
Keep it short and to the point. 0.59. What is the ratio of the Payments (BoP, current US$) of Greece in 2008 to that in 2011?
Your answer should be compact. 1.41. What is the ratio of the Payments (BoP, current US$) in Kiribati in 2008 to that in 2011?
Your response must be concise. 0.84. What is the ratio of the Payments (BoP, current US$) in Niger in 2008 to that in 2011?
Offer a terse response. 0.63. What is the ratio of the Payments (BoP, current US$) of Bhutan in 2009 to that in 2010?
Your response must be concise. 0.72. What is the ratio of the Payments (BoP, current US$) in Greece in 2009 to that in 2010?
Your answer should be very brief. 1.07. What is the ratio of the Payments (BoP, current US$) of Niger in 2009 to that in 2010?
Give a very brief answer. 0.91. What is the ratio of the Payments (BoP, current US$) of Bhutan in 2009 to that in 2011?
Your response must be concise. 0.52. What is the ratio of the Payments (BoP, current US$) of Greece in 2009 to that in 2011?
Your response must be concise. 1.01. What is the ratio of the Payments (BoP, current US$) of Kiribati in 2009 to that in 2011?
Your answer should be compact. 0.78. What is the ratio of the Payments (BoP, current US$) in Niger in 2009 to that in 2011?
Offer a very short reply. 0.83. What is the ratio of the Payments (BoP, current US$) of Bhutan in 2010 to that in 2011?
Provide a short and direct response. 0.72. What is the ratio of the Payments (BoP, current US$) in Greece in 2010 to that in 2011?
Your answer should be compact. 0.94. What is the ratio of the Payments (BoP, current US$) of Kiribati in 2010 to that in 2011?
Ensure brevity in your answer.  0.78. What is the ratio of the Payments (BoP, current US$) in Niger in 2010 to that in 2011?
Provide a short and direct response. 0.91. What is the difference between the highest and the second highest Payments (BoP, current US$) in Bhutan?
Offer a very short reply. 4.02e+08. What is the difference between the highest and the second highest Payments (BoP, current US$) of Greece?
Your answer should be compact. 2.34e+1. What is the difference between the highest and the second highest Payments (BoP, current US$) of Kiribati?
Your response must be concise. 2.46e+07. What is the difference between the highest and the second highest Payments (BoP, current US$) in Niger?
Make the answer very short. 2.90e+08. What is the difference between the highest and the lowest Payments (BoP, current US$) in Bhutan?
Offer a terse response. 9.01e+08. What is the difference between the highest and the lowest Payments (BoP, current US$) of Greece?
Your response must be concise. 4.91e+1. What is the difference between the highest and the lowest Payments (BoP, current US$) of Kiribati?
Make the answer very short. 5.52e+07. What is the difference between the highest and the lowest Payments (BoP, current US$) in Niger?
Offer a very short reply. 2.09e+09. 